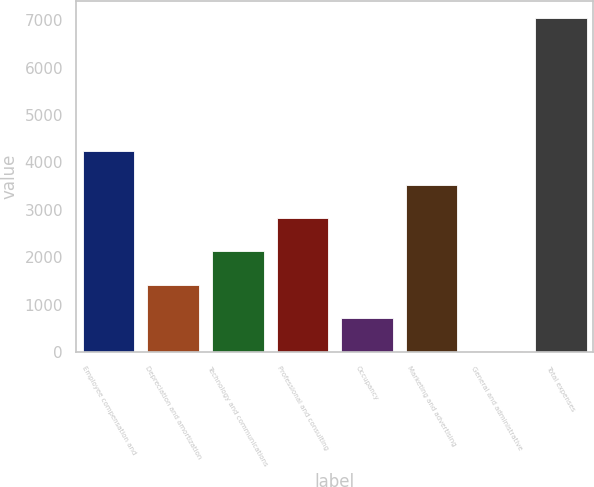Convert chart. <chart><loc_0><loc_0><loc_500><loc_500><bar_chart><fcel>Employee compensation and<fcel>Depreciation and amortization<fcel>Technology and communications<fcel>Professional and consulting<fcel>Occupancy<fcel>Marketing and advertising<fcel>General and administrative<fcel>Total expenses<nl><fcel>4236.4<fcel>1424.8<fcel>2127.7<fcel>2830.6<fcel>721.9<fcel>3533.5<fcel>19<fcel>7048<nl></chart> 